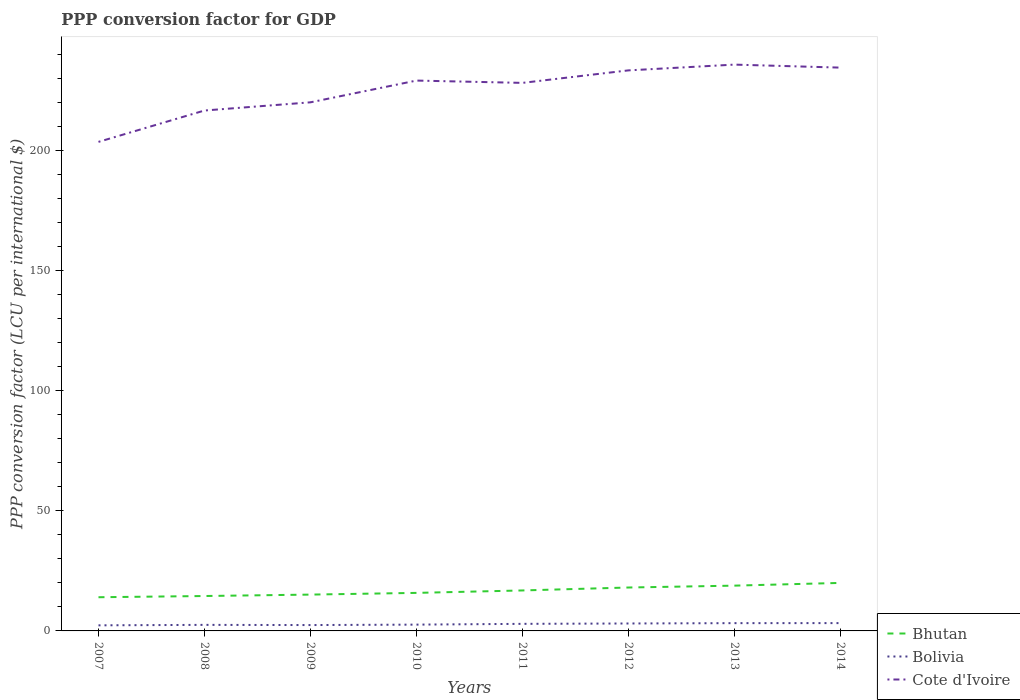Does the line corresponding to Bhutan intersect with the line corresponding to Bolivia?
Keep it short and to the point. No. Is the number of lines equal to the number of legend labels?
Make the answer very short. Yes. Across all years, what is the maximum PPP conversion factor for GDP in Bolivia?
Your answer should be compact. 2.33. In which year was the PPP conversion factor for GDP in Bolivia maximum?
Offer a terse response. 2007. What is the total PPP conversion factor for GDP in Cote d'Ivoire in the graph?
Ensure brevity in your answer.  -6.65. What is the difference between the highest and the second highest PPP conversion factor for GDP in Bolivia?
Ensure brevity in your answer.  0.93. Is the PPP conversion factor for GDP in Bolivia strictly greater than the PPP conversion factor for GDP in Cote d'Ivoire over the years?
Keep it short and to the point. Yes. How many lines are there?
Keep it short and to the point. 3. How many years are there in the graph?
Ensure brevity in your answer.  8. What is the difference between two consecutive major ticks on the Y-axis?
Make the answer very short. 50. Does the graph contain any zero values?
Offer a terse response. No. How many legend labels are there?
Provide a succinct answer. 3. How are the legend labels stacked?
Make the answer very short. Vertical. What is the title of the graph?
Ensure brevity in your answer.  PPP conversion factor for GDP. What is the label or title of the X-axis?
Provide a succinct answer. Years. What is the label or title of the Y-axis?
Offer a very short reply. PPP conversion factor (LCU per international $). What is the PPP conversion factor (LCU per international $) of Bhutan in 2007?
Provide a short and direct response. 14.03. What is the PPP conversion factor (LCU per international $) of Bolivia in 2007?
Your answer should be compact. 2.33. What is the PPP conversion factor (LCU per international $) in Cote d'Ivoire in 2007?
Ensure brevity in your answer.  203.66. What is the PPP conversion factor (LCU per international $) of Bhutan in 2008?
Your answer should be very brief. 14.54. What is the PPP conversion factor (LCU per international $) of Bolivia in 2008?
Ensure brevity in your answer.  2.52. What is the PPP conversion factor (LCU per international $) in Cote d'Ivoire in 2008?
Keep it short and to the point. 216.72. What is the PPP conversion factor (LCU per international $) of Bhutan in 2009?
Your answer should be very brief. 15.13. What is the PPP conversion factor (LCU per international $) of Bolivia in 2009?
Ensure brevity in your answer.  2.44. What is the PPP conversion factor (LCU per international $) of Cote d'Ivoire in 2009?
Your response must be concise. 220.13. What is the PPP conversion factor (LCU per international $) in Bhutan in 2010?
Give a very brief answer. 15.84. What is the PPP conversion factor (LCU per international $) in Bolivia in 2010?
Offer a terse response. 2.62. What is the PPP conversion factor (LCU per international $) in Cote d'Ivoire in 2010?
Keep it short and to the point. 229.19. What is the PPP conversion factor (LCU per international $) in Bhutan in 2011?
Your response must be concise. 16.86. What is the PPP conversion factor (LCU per international $) of Bolivia in 2011?
Your answer should be very brief. 2.95. What is the PPP conversion factor (LCU per international $) of Cote d'Ivoire in 2011?
Make the answer very short. 228.23. What is the PPP conversion factor (LCU per international $) of Bhutan in 2012?
Make the answer very short. 18.08. What is the PPP conversion factor (LCU per international $) of Bolivia in 2012?
Offer a terse response. 3.1. What is the PPP conversion factor (LCU per international $) in Cote d'Ivoire in 2012?
Your answer should be very brief. 233.43. What is the PPP conversion factor (LCU per international $) of Bhutan in 2013?
Provide a succinct answer. 18.86. What is the PPP conversion factor (LCU per international $) in Bolivia in 2013?
Offer a terse response. 3.24. What is the PPP conversion factor (LCU per international $) in Cote d'Ivoire in 2013?
Keep it short and to the point. 235.84. What is the PPP conversion factor (LCU per international $) of Bhutan in 2014?
Keep it short and to the point. 19.99. What is the PPP conversion factor (LCU per international $) in Bolivia in 2014?
Offer a very short reply. 3.26. What is the PPP conversion factor (LCU per international $) in Cote d'Ivoire in 2014?
Give a very brief answer. 234.59. Across all years, what is the maximum PPP conversion factor (LCU per international $) of Bhutan?
Keep it short and to the point. 19.99. Across all years, what is the maximum PPP conversion factor (LCU per international $) in Bolivia?
Your answer should be compact. 3.26. Across all years, what is the maximum PPP conversion factor (LCU per international $) of Cote d'Ivoire?
Your response must be concise. 235.84. Across all years, what is the minimum PPP conversion factor (LCU per international $) in Bhutan?
Offer a terse response. 14.03. Across all years, what is the minimum PPP conversion factor (LCU per international $) of Bolivia?
Provide a succinct answer. 2.33. Across all years, what is the minimum PPP conversion factor (LCU per international $) in Cote d'Ivoire?
Keep it short and to the point. 203.66. What is the total PPP conversion factor (LCU per international $) in Bhutan in the graph?
Keep it short and to the point. 133.32. What is the total PPP conversion factor (LCU per international $) in Bolivia in the graph?
Your response must be concise. 22.45. What is the total PPP conversion factor (LCU per international $) in Cote d'Ivoire in the graph?
Provide a short and direct response. 1801.79. What is the difference between the PPP conversion factor (LCU per international $) of Bhutan in 2007 and that in 2008?
Keep it short and to the point. -0.51. What is the difference between the PPP conversion factor (LCU per international $) of Bolivia in 2007 and that in 2008?
Your answer should be very brief. -0.19. What is the difference between the PPP conversion factor (LCU per international $) of Cote d'Ivoire in 2007 and that in 2008?
Keep it short and to the point. -13.06. What is the difference between the PPP conversion factor (LCU per international $) of Bhutan in 2007 and that in 2009?
Your response must be concise. -1.1. What is the difference between the PPP conversion factor (LCU per international $) in Bolivia in 2007 and that in 2009?
Ensure brevity in your answer.  -0.11. What is the difference between the PPP conversion factor (LCU per international $) in Cote d'Ivoire in 2007 and that in 2009?
Give a very brief answer. -16.48. What is the difference between the PPP conversion factor (LCU per international $) in Bhutan in 2007 and that in 2010?
Your answer should be very brief. -1.81. What is the difference between the PPP conversion factor (LCU per international $) of Bolivia in 2007 and that in 2010?
Provide a succinct answer. -0.29. What is the difference between the PPP conversion factor (LCU per international $) of Cote d'Ivoire in 2007 and that in 2010?
Your answer should be compact. -25.53. What is the difference between the PPP conversion factor (LCU per international $) of Bhutan in 2007 and that in 2011?
Give a very brief answer. -2.83. What is the difference between the PPP conversion factor (LCU per international $) in Bolivia in 2007 and that in 2011?
Keep it short and to the point. -0.62. What is the difference between the PPP conversion factor (LCU per international $) in Cote d'Ivoire in 2007 and that in 2011?
Provide a short and direct response. -24.57. What is the difference between the PPP conversion factor (LCU per international $) of Bhutan in 2007 and that in 2012?
Ensure brevity in your answer.  -4.05. What is the difference between the PPP conversion factor (LCU per international $) of Bolivia in 2007 and that in 2012?
Provide a short and direct response. -0.77. What is the difference between the PPP conversion factor (LCU per international $) of Cote d'Ivoire in 2007 and that in 2012?
Provide a short and direct response. -29.78. What is the difference between the PPP conversion factor (LCU per international $) in Bhutan in 2007 and that in 2013?
Offer a very short reply. -4.83. What is the difference between the PPP conversion factor (LCU per international $) in Bolivia in 2007 and that in 2013?
Keep it short and to the point. -0.91. What is the difference between the PPP conversion factor (LCU per international $) of Cote d'Ivoire in 2007 and that in 2013?
Your response must be concise. -32.18. What is the difference between the PPP conversion factor (LCU per international $) in Bhutan in 2007 and that in 2014?
Keep it short and to the point. -5.96. What is the difference between the PPP conversion factor (LCU per international $) in Bolivia in 2007 and that in 2014?
Make the answer very short. -0.93. What is the difference between the PPP conversion factor (LCU per international $) of Cote d'Ivoire in 2007 and that in 2014?
Your answer should be compact. -30.93. What is the difference between the PPP conversion factor (LCU per international $) of Bhutan in 2008 and that in 2009?
Make the answer very short. -0.59. What is the difference between the PPP conversion factor (LCU per international $) in Bolivia in 2008 and that in 2009?
Your answer should be very brief. 0.08. What is the difference between the PPP conversion factor (LCU per international $) in Cote d'Ivoire in 2008 and that in 2009?
Offer a very short reply. -3.41. What is the difference between the PPP conversion factor (LCU per international $) in Bhutan in 2008 and that in 2010?
Your answer should be compact. -1.3. What is the difference between the PPP conversion factor (LCU per international $) in Bolivia in 2008 and that in 2010?
Keep it short and to the point. -0.1. What is the difference between the PPP conversion factor (LCU per international $) of Cote d'Ivoire in 2008 and that in 2010?
Your answer should be compact. -12.47. What is the difference between the PPP conversion factor (LCU per international $) in Bhutan in 2008 and that in 2011?
Give a very brief answer. -2.32. What is the difference between the PPP conversion factor (LCU per international $) in Bolivia in 2008 and that in 2011?
Provide a short and direct response. -0.42. What is the difference between the PPP conversion factor (LCU per international $) of Cote d'Ivoire in 2008 and that in 2011?
Make the answer very short. -11.51. What is the difference between the PPP conversion factor (LCU per international $) of Bhutan in 2008 and that in 2012?
Provide a short and direct response. -3.54. What is the difference between the PPP conversion factor (LCU per international $) in Bolivia in 2008 and that in 2012?
Give a very brief answer. -0.58. What is the difference between the PPP conversion factor (LCU per international $) of Cote d'Ivoire in 2008 and that in 2012?
Ensure brevity in your answer.  -16.71. What is the difference between the PPP conversion factor (LCU per international $) of Bhutan in 2008 and that in 2013?
Keep it short and to the point. -4.32. What is the difference between the PPP conversion factor (LCU per international $) of Bolivia in 2008 and that in 2013?
Provide a succinct answer. -0.72. What is the difference between the PPP conversion factor (LCU per international $) of Cote d'Ivoire in 2008 and that in 2013?
Keep it short and to the point. -19.12. What is the difference between the PPP conversion factor (LCU per international $) of Bhutan in 2008 and that in 2014?
Ensure brevity in your answer.  -5.46. What is the difference between the PPP conversion factor (LCU per international $) of Bolivia in 2008 and that in 2014?
Offer a very short reply. -0.73. What is the difference between the PPP conversion factor (LCU per international $) of Cote d'Ivoire in 2008 and that in 2014?
Make the answer very short. -17.86. What is the difference between the PPP conversion factor (LCU per international $) of Bhutan in 2009 and that in 2010?
Give a very brief answer. -0.71. What is the difference between the PPP conversion factor (LCU per international $) of Bolivia in 2009 and that in 2010?
Your answer should be very brief. -0.18. What is the difference between the PPP conversion factor (LCU per international $) of Cote d'Ivoire in 2009 and that in 2010?
Your response must be concise. -9.06. What is the difference between the PPP conversion factor (LCU per international $) of Bhutan in 2009 and that in 2011?
Offer a very short reply. -1.73. What is the difference between the PPP conversion factor (LCU per international $) of Bolivia in 2009 and that in 2011?
Your answer should be compact. -0.5. What is the difference between the PPP conversion factor (LCU per international $) in Cote d'Ivoire in 2009 and that in 2011?
Offer a terse response. -8.09. What is the difference between the PPP conversion factor (LCU per international $) in Bhutan in 2009 and that in 2012?
Your answer should be very brief. -2.95. What is the difference between the PPP conversion factor (LCU per international $) in Bolivia in 2009 and that in 2012?
Ensure brevity in your answer.  -0.66. What is the difference between the PPP conversion factor (LCU per international $) in Cote d'Ivoire in 2009 and that in 2012?
Give a very brief answer. -13.3. What is the difference between the PPP conversion factor (LCU per international $) of Bhutan in 2009 and that in 2013?
Give a very brief answer. -3.73. What is the difference between the PPP conversion factor (LCU per international $) of Bolivia in 2009 and that in 2013?
Your answer should be compact. -0.8. What is the difference between the PPP conversion factor (LCU per international $) in Cote d'Ivoire in 2009 and that in 2013?
Make the answer very short. -15.7. What is the difference between the PPP conversion factor (LCU per international $) in Bhutan in 2009 and that in 2014?
Provide a short and direct response. -4.87. What is the difference between the PPP conversion factor (LCU per international $) of Bolivia in 2009 and that in 2014?
Your answer should be very brief. -0.81. What is the difference between the PPP conversion factor (LCU per international $) in Cote d'Ivoire in 2009 and that in 2014?
Offer a terse response. -14.45. What is the difference between the PPP conversion factor (LCU per international $) in Bhutan in 2010 and that in 2011?
Ensure brevity in your answer.  -1.02. What is the difference between the PPP conversion factor (LCU per international $) in Bolivia in 2010 and that in 2011?
Your answer should be compact. -0.32. What is the difference between the PPP conversion factor (LCU per international $) of Cote d'Ivoire in 2010 and that in 2011?
Your answer should be compact. 0.96. What is the difference between the PPP conversion factor (LCU per international $) in Bhutan in 2010 and that in 2012?
Give a very brief answer. -2.24. What is the difference between the PPP conversion factor (LCU per international $) of Bolivia in 2010 and that in 2012?
Provide a short and direct response. -0.48. What is the difference between the PPP conversion factor (LCU per international $) of Cote d'Ivoire in 2010 and that in 2012?
Your answer should be very brief. -4.24. What is the difference between the PPP conversion factor (LCU per international $) in Bhutan in 2010 and that in 2013?
Provide a succinct answer. -3.02. What is the difference between the PPP conversion factor (LCU per international $) in Bolivia in 2010 and that in 2013?
Provide a succinct answer. -0.61. What is the difference between the PPP conversion factor (LCU per international $) in Cote d'Ivoire in 2010 and that in 2013?
Make the answer very short. -6.65. What is the difference between the PPP conversion factor (LCU per international $) of Bhutan in 2010 and that in 2014?
Provide a short and direct response. -4.15. What is the difference between the PPP conversion factor (LCU per international $) of Bolivia in 2010 and that in 2014?
Your response must be concise. -0.63. What is the difference between the PPP conversion factor (LCU per international $) in Cote d'Ivoire in 2010 and that in 2014?
Your response must be concise. -5.39. What is the difference between the PPP conversion factor (LCU per international $) in Bhutan in 2011 and that in 2012?
Make the answer very short. -1.22. What is the difference between the PPP conversion factor (LCU per international $) of Bolivia in 2011 and that in 2012?
Your answer should be very brief. -0.15. What is the difference between the PPP conversion factor (LCU per international $) in Cote d'Ivoire in 2011 and that in 2012?
Make the answer very short. -5.21. What is the difference between the PPP conversion factor (LCU per international $) in Bhutan in 2011 and that in 2013?
Ensure brevity in your answer.  -2. What is the difference between the PPP conversion factor (LCU per international $) of Bolivia in 2011 and that in 2013?
Provide a short and direct response. -0.29. What is the difference between the PPP conversion factor (LCU per international $) of Cote d'Ivoire in 2011 and that in 2013?
Ensure brevity in your answer.  -7.61. What is the difference between the PPP conversion factor (LCU per international $) of Bhutan in 2011 and that in 2014?
Provide a short and direct response. -3.14. What is the difference between the PPP conversion factor (LCU per international $) in Bolivia in 2011 and that in 2014?
Your answer should be compact. -0.31. What is the difference between the PPP conversion factor (LCU per international $) of Cote d'Ivoire in 2011 and that in 2014?
Offer a very short reply. -6.36. What is the difference between the PPP conversion factor (LCU per international $) of Bhutan in 2012 and that in 2013?
Make the answer very short. -0.78. What is the difference between the PPP conversion factor (LCU per international $) in Bolivia in 2012 and that in 2013?
Your response must be concise. -0.14. What is the difference between the PPP conversion factor (LCU per international $) of Cote d'Ivoire in 2012 and that in 2013?
Provide a succinct answer. -2.4. What is the difference between the PPP conversion factor (LCU per international $) of Bhutan in 2012 and that in 2014?
Give a very brief answer. -1.92. What is the difference between the PPP conversion factor (LCU per international $) of Bolivia in 2012 and that in 2014?
Offer a terse response. -0.16. What is the difference between the PPP conversion factor (LCU per international $) in Cote d'Ivoire in 2012 and that in 2014?
Provide a short and direct response. -1.15. What is the difference between the PPP conversion factor (LCU per international $) in Bhutan in 2013 and that in 2014?
Provide a short and direct response. -1.14. What is the difference between the PPP conversion factor (LCU per international $) in Bolivia in 2013 and that in 2014?
Keep it short and to the point. -0.02. What is the difference between the PPP conversion factor (LCU per international $) of Cote d'Ivoire in 2013 and that in 2014?
Ensure brevity in your answer.  1.25. What is the difference between the PPP conversion factor (LCU per international $) of Bhutan in 2007 and the PPP conversion factor (LCU per international $) of Bolivia in 2008?
Make the answer very short. 11.51. What is the difference between the PPP conversion factor (LCU per international $) in Bhutan in 2007 and the PPP conversion factor (LCU per international $) in Cote d'Ivoire in 2008?
Offer a terse response. -202.69. What is the difference between the PPP conversion factor (LCU per international $) in Bolivia in 2007 and the PPP conversion factor (LCU per international $) in Cote d'Ivoire in 2008?
Your response must be concise. -214.39. What is the difference between the PPP conversion factor (LCU per international $) in Bhutan in 2007 and the PPP conversion factor (LCU per international $) in Bolivia in 2009?
Provide a succinct answer. 11.59. What is the difference between the PPP conversion factor (LCU per international $) in Bhutan in 2007 and the PPP conversion factor (LCU per international $) in Cote d'Ivoire in 2009?
Give a very brief answer. -206.1. What is the difference between the PPP conversion factor (LCU per international $) in Bolivia in 2007 and the PPP conversion factor (LCU per international $) in Cote d'Ivoire in 2009?
Make the answer very short. -217.81. What is the difference between the PPP conversion factor (LCU per international $) of Bhutan in 2007 and the PPP conversion factor (LCU per international $) of Bolivia in 2010?
Your response must be concise. 11.41. What is the difference between the PPP conversion factor (LCU per international $) of Bhutan in 2007 and the PPP conversion factor (LCU per international $) of Cote d'Ivoire in 2010?
Offer a terse response. -215.16. What is the difference between the PPP conversion factor (LCU per international $) of Bolivia in 2007 and the PPP conversion factor (LCU per international $) of Cote d'Ivoire in 2010?
Ensure brevity in your answer.  -226.86. What is the difference between the PPP conversion factor (LCU per international $) in Bhutan in 2007 and the PPP conversion factor (LCU per international $) in Bolivia in 2011?
Your answer should be compact. 11.08. What is the difference between the PPP conversion factor (LCU per international $) in Bhutan in 2007 and the PPP conversion factor (LCU per international $) in Cote d'Ivoire in 2011?
Provide a short and direct response. -214.2. What is the difference between the PPP conversion factor (LCU per international $) in Bolivia in 2007 and the PPP conversion factor (LCU per international $) in Cote d'Ivoire in 2011?
Your answer should be compact. -225.9. What is the difference between the PPP conversion factor (LCU per international $) of Bhutan in 2007 and the PPP conversion factor (LCU per international $) of Bolivia in 2012?
Ensure brevity in your answer.  10.93. What is the difference between the PPP conversion factor (LCU per international $) in Bhutan in 2007 and the PPP conversion factor (LCU per international $) in Cote d'Ivoire in 2012?
Offer a very short reply. -219.4. What is the difference between the PPP conversion factor (LCU per international $) in Bolivia in 2007 and the PPP conversion factor (LCU per international $) in Cote d'Ivoire in 2012?
Ensure brevity in your answer.  -231.11. What is the difference between the PPP conversion factor (LCU per international $) of Bhutan in 2007 and the PPP conversion factor (LCU per international $) of Bolivia in 2013?
Give a very brief answer. 10.79. What is the difference between the PPP conversion factor (LCU per international $) in Bhutan in 2007 and the PPP conversion factor (LCU per international $) in Cote d'Ivoire in 2013?
Keep it short and to the point. -221.81. What is the difference between the PPP conversion factor (LCU per international $) of Bolivia in 2007 and the PPP conversion factor (LCU per international $) of Cote d'Ivoire in 2013?
Offer a terse response. -233.51. What is the difference between the PPP conversion factor (LCU per international $) in Bhutan in 2007 and the PPP conversion factor (LCU per international $) in Bolivia in 2014?
Keep it short and to the point. 10.77. What is the difference between the PPP conversion factor (LCU per international $) in Bhutan in 2007 and the PPP conversion factor (LCU per international $) in Cote d'Ivoire in 2014?
Your answer should be compact. -220.56. What is the difference between the PPP conversion factor (LCU per international $) in Bolivia in 2007 and the PPP conversion factor (LCU per international $) in Cote d'Ivoire in 2014?
Provide a succinct answer. -232.26. What is the difference between the PPP conversion factor (LCU per international $) of Bhutan in 2008 and the PPP conversion factor (LCU per international $) of Bolivia in 2009?
Provide a succinct answer. 12.1. What is the difference between the PPP conversion factor (LCU per international $) of Bhutan in 2008 and the PPP conversion factor (LCU per international $) of Cote d'Ivoire in 2009?
Keep it short and to the point. -205.6. What is the difference between the PPP conversion factor (LCU per international $) of Bolivia in 2008 and the PPP conversion factor (LCU per international $) of Cote d'Ivoire in 2009?
Offer a terse response. -217.61. What is the difference between the PPP conversion factor (LCU per international $) in Bhutan in 2008 and the PPP conversion factor (LCU per international $) in Bolivia in 2010?
Your response must be concise. 11.91. What is the difference between the PPP conversion factor (LCU per international $) of Bhutan in 2008 and the PPP conversion factor (LCU per international $) of Cote d'Ivoire in 2010?
Ensure brevity in your answer.  -214.65. What is the difference between the PPP conversion factor (LCU per international $) in Bolivia in 2008 and the PPP conversion factor (LCU per international $) in Cote d'Ivoire in 2010?
Keep it short and to the point. -226.67. What is the difference between the PPP conversion factor (LCU per international $) of Bhutan in 2008 and the PPP conversion factor (LCU per international $) of Bolivia in 2011?
Your answer should be very brief. 11.59. What is the difference between the PPP conversion factor (LCU per international $) in Bhutan in 2008 and the PPP conversion factor (LCU per international $) in Cote d'Ivoire in 2011?
Give a very brief answer. -213.69. What is the difference between the PPP conversion factor (LCU per international $) of Bolivia in 2008 and the PPP conversion factor (LCU per international $) of Cote d'Ivoire in 2011?
Keep it short and to the point. -225.71. What is the difference between the PPP conversion factor (LCU per international $) in Bhutan in 2008 and the PPP conversion factor (LCU per international $) in Bolivia in 2012?
Keep it short and to the point. 11.44. What is the difference between the PPP conversion factor (LCU per international $) of Bhutan in 2008 and the PPP conversion factor (LCU per international $) of Cote d'Ivoire in 2012?
Your response must be concise. -218.9. What is the difference between the PPP conversion factor (LCU per international $) of Bolivia in 2008 and the PPP conversion factor (LCU per international $) of Cote d'Ivoire in 2012?
Keep it short and to the point. -230.91. What is the difference between the PPP conversion factor (LCU per international $) of Bhutan in 2008 and the PPP conversion factor (LCU per international $) of Bolivia in 2013?
Provide a short and direct response. 11.3. What is the difference between the PPP conversion factor (LCU per international $) of Bhutan in 2008 and the PPP conversion factor (LCU per international $) of Cote d'Ivoire in 2013?
Offer a very short reply. -221.3. What is the difference between the PPP conversion factor (LCU per international $) in Bolivia in 2008 and the PPP conversion factor (LCU per international $) in Cote d'Ivoire in 2013?
Make the answer very short. -233.32. What is the difference between the PPP conversion factor (LCU per international $) in Bhutan in 2008 and the PPP conversion factor (LCU per international $) in Bolivia in 2014?
Your response must be concise. 11.28. What is the difference between the PPP conversion factor (LCU per international $) in Bhutan in 2008 and the PPP conversion factor (LCU per international $) in Cote d'Ivoire in 2014?
Your answer should be compact. -220.05. What is the difference between the PPP conversion factor (LCU per international $) of Bolivia in 2008 and the PPP conversion factor (LCU per international $) of Cote d'Ivoire in 2014?
Ensure brevity in your answer.  -232.07. What is the difference between the PPP conversion factor (LCU per international $) of Bhutan in 2009 and the PPP conversion factor (LCU per international $) of Bolivia in 2010?
Offer a terse response. 12.5. What is the difference between the PPP conversion factor (LCU per international $) of Bhutan in 2009 and the PPP conversion factor (LCU per international $) of Cote d'Ivoire in 2010?
Provide a short and direct response. -214.06. What is the difference between the PPP conversion factor (LCU per international $) in Bolivia in 2009 and the PPP conversion factor (LCU per international $) in Cote d'Ivoire in 2010?
Your response must be concise. -226.75. What is the difference between the PPP conversion factor (LCU per international $) of Bhutan in 2009 and the PPP conversion factor (LCU per international $) of Bolivia in 2011?
Your answer should be compact. 12.18. What is the difference between the PPP conversion factor (LCU per international $) in Bhutan in 2009 and the PPP conversion factor (LCU per international $) in Cote d'Ivoire in 2011?
Offer a terse response. -213.1. What is the difference between the PPP conversion factor (LCU per international $) in Bolivia in 2009 and the PPP conversion factor (LCU per international $) in Cote d'Ivoire in 2011?
Your answer should be very brief. -225.79. What is the difference between the PPP conversion factor (LCU per international $) in Bhutan in 2009 and the PPP conversion factor (LCU per international $) in Bolivia in 2012?
Provide a short and direct response. 12.03. What is the difference between the PPP conversion factor (LCU per international $) of Bhutan in 2009 and the PPP conversion factor (LCU per international $) of Cote d'Ivoire in 2012?
Provide a succinct answer. -218.31. What is the difference between the PPP conversion factor (LCU per international $) in Bolivia in 2009 and the PPP conversion factor (LCU per international $) in Cote d'Ivoire in 2012?
Ensure brevity in your answer.  -230.99. What is the difference between the PPP conversion factor (LCU per international $) in Bhutan in 2009 and the PPP conversion factor (LCU per international $) in Bolivia in 2013?
Provide a succinct answer. 11.89. What is the difference between the PPP conversion factor (LCU per international $) of Bhutan in 2009 and the PPP conversion factor (LCU per international $) of Cote d'Ivoire in 2013?
Your answer should be compact. -220.71. What is the difference between the PPP conversion factor (LCU per international $) in Bolivia in 2009 and the PPP conversion factor (LCU per international $) in Cote d'Ivoire in 2013?
Provide a short and direct response. -233.4. What is the difference between the PPP conversion factor (LCU per international $) in Bhutan in 2009 and the PPP conversion factor (LCU per international $) in Bolivia in 2014?
Offer a terse response. 11.87. What is the difference between the PPP conversion factor (LCU per international $) in Bhutan in 2009 and the PPP conversion factor (LCU per international $) in Cote d'Ivoire in 2014?
Provide a short and direct response. -219.46. What is the difference between the PPP conversion factor (LCU per international $) of Bolivia in 2009 and the PPP conversion factor (LCU per international $) of Cote d'Ivoire in 2014?
Provide a short and direct response. -232.14. What is the difference between the PPP conversion factor (LCU per international $) in Bhutan in 2010 and the PPP conversion factor (LCU per international $) in Bolivia in 2011?
Your answer should be very brief. 12.89. What is the difference between the PPP conversion factor (LCU per international $) in Bhutan in 2010 and the PPP conversion factor (LCU per international $) in Cote d'Ivoire in 2011?
Give a very brief answer. -212.39. What is the difference between the PPP conversion factor (LCU per international $) of Bolivia in 2010 and the PPP conversion factor (LCU per international $) of Cote d'Ivoire in 2011?
Your response must be concise. -225.6. What is the difference between the PPP conversion factor (LCU per international $) in Bhutan in 2010 and the PPP conversion factor (LCU per international $) in Bolivia in 2012?
Provide a succinct answer. 12.74. What is the difference between the PPP conversion factor (LCU per international $) in Bhutan in 2010 and the PPP conversion factor (LCU per international $) in Cote d'Ivoire in 2012?
Offer a very short reply. -217.59. What is the difference between the PPP conversion factor (LCU per international $) in Bolivia in 2010 and the PPP conversion factor (LCU per international $) in Cote d'Ivoire in 2012?
Your answer should be very brief. -230.81. What is the difference between the PPP conversion factor (LCU per international $) of Bhutan in 2010 and the PPP conversion factor (LCU per international $) of Bolivia in 2013?
Your answer should be compact. 12.6. What is the difference between the PPP conversion factor (LCU per international $) of Bhutan in 2010 and the PPP conversion factor (LCU per international $) of Cote d'Ivoire in 2013?
Your response must be concise. -220. What is the difference between the PPP conversion factor (LCU per international $) in Bolivia in 2010 and the PPP conversion factor (LCU per international $) in Cote d'Ivoire in 2013?
Keep it short and to the point. -233.21. What is the difference between the PPP conversion factor (LCU per international $) of Bhutan in 2010 and the PPP conversion factor (LCU per international $) of Bolivia in 2014?
Give a very brief answer. 12.58. What is the difference between the PPP conversion factor (LCU per international $) in Bhutan in 2010 and the PPP conversion factor (LCU per international $) in Cote d'Ivoire in 2014?
Provide a short and direct response. -218.75. What is the difference between the PPP conversion factor (LCU per international $) of Bolivia in 2010 and the PPP conversion factor (LCU per international $) of Cote d'Ivoire in 2014?
Provide a succinct answer. -231.96. What is the difference between the PPP conversion factor (LCU per international $) of Bhutan in 2011 and the PPP conversion factor (LCU per international $) of Bolivia in 2012?
Offer a terse response. 13.76. What is the difference between the PPP conversion factor (LCU per international $) of Bhutan in 2011 and the PPP conversion factor (LCU per international $) of Cote d'Ivoire in 2012?
Your answer should be very brief. -216.58. What is the difference between the PPP conversion factor (LCU per international $) in Bolivia in 2011 and the PPP conversion factor (LCU per international $) in Cote d'Ivoire in 2012?
Provide a short and direct response. -230.49. What is the difference between the PPP conversion factor (LCU per international $) in Bhutan in 2011 and the PPP conversion factor (LCU per international $) in Bolivia in 2013?
Make the answer very short. 13.62. What is the difference between the PPP conversion factor (LCU per international $) of Bhutan in 2011 and the PPP conversion factor (LCU per international $) of Cote d'Ivoire in 2013?
Ensure brevity in your answer.  -218.98. What is the difference between the PPP conversion factor (LCU per international $) in Bolivia in 2011 and the PPP conversion factor (LCU per international $) in Cote d'Ivoire in 2013?
Your response must be concise. -232.89. What is the difference between the PPP conversion factor (LCU per international $) in Bhutan in 2011 and the PPP conversion factor (LCU per international $) in Bolivia in 2014?
Your answer should be compact. 13.6. What is the difference between the PPP conversion factor (LCU per international $) in Bhutan in 2011 and the PPP conversion factor (LCU per international $) in Cote d'Ivoire in 2014?
Your answer should be compact. -217.73. What is the difference between the PPP conversion factor (LCU per international $) of Bolivia in 2011 and the PPP conversion factor (LCU per international $) of Cote d'Ivoire in 2014?
Give a very brief answer. -231.64. What is the difference between the PPP conversion factor (LCU per international $) in Bhutan in 2012 and the PPP conversion factor (LCU per international $) in Bolivia in 2013?
Your answer should be compact. 14.84. What is the difference between the PPP conversion factor (LCU per international $) of Bhutan in 2012 and the PPP conversion factor (LCU per international $) of Cote d'Ivoire in 2013?
Your answer should be very brief. -217.76. What is the difference between the PPP conversion factor (LCU per international $) of Bolivia in 2012 and the PPP conversion factor (LCU per international $) of Cote d'Ivoire in 2013?
Your answer should be compact. -232.74. What is the difference between the PPP conversion factor (LCU per international $) of Bhutan in 2012 and the PPP conversion factor (LCU per international $) of Bolivia in 2014?
Your answer should be very brief. 14.82. What is the difference between the PPP conversion factor (LCU per international $) in Bhutan in 2012 and the PPP conversion factor (LCU per international $) in Cote d'Ivoire in 2014?
Offer a terse response. -216.51. What is the difference between the PPP conversion factor (LCU per international $) of Bolivia in 2012 and the PPP conversion factor (LCU per international $) of Cote d'Ivoire in 2014?
Offer a terse response. -231.49. What is the difference between the PPP conversion factor (LCU per international $) of Bhutan in 2013 and the PPP conversion factor (LCU per international $) of Bolivia in 2014?
Keep it short and to the point. 15.6. What is the difference between the PPP conversion factor (LCU per international $) of Bhutan in 2013 and the PPP conversion factor (LCU per international $) of Cote d'Ivoire in 2014?
Your answer should be compact. -215.73. What is the difference between the PPP conversion factor (LCU per international $) of Bolivia in 2013 and the PPP conversion factor (LCU per international $) of Cote d'Ivoire in 2014?
Provide a succinct answer. -231.35. What is the average PPP conversion factor (LCU per international $) of Bhutan per year?
Your answer should be very brief. 16.67. What is the average PPP conversion factor (LCU per international $) of Bolivia per year?
Ensure brevity in your answer.  2.81. What is the average PPP conversion factor (LCU per international $) of Cote d'Ivoire per year?
Your response must be concise. 225.22. In the year 2007, what is the difference between the PPP conversion factor (LCU per international $) of Bhutan and PPP conversion factor (LCU per international $) of Bolivia?
Make the answer very short. 11.7. In the year 2007, what is the difference between the PPP conversion factor (LCU per international $) of Bhutan and PPP conversion factor (LCU per international $) of Cote d'Ivoire?
Keep it short and to the point. -189.63. In the year 2007, what is the difference between the PPP conversion factor (LCU per international $) of Bolivia and PPP conversion factor (LCU per international $) of Cote d'Ivoire?
Your answer should be very brief. -201.33. In the year 2008, what is the difference between the PPP conversion factor (LCU per international $) of Bhutan and PPP conversion factor (LCU per international $) of Bolivia?
Offer a terse response. 12.02. In the year 2008, what is the difference between the PPP conversion factor (LCU per international $) of Bhutan and PPP conversion factor (LCU per international $) of Cote d'Ivoire?
Your answer should be very brief. -202.18. In the year 2008, what is the difference between the PPP conversion factor (LCU per international $) in Bolivia and PPP conversion factor (LCU per international $) in Cote d'Ivoire?
Offer a very short reply. -214.2. In the year 2009, what is the difference between the PPP conversion factor (LCU per international $) of Bhutan and PPP conversion factor (LCU per international $) of Bolivia?
Offer a very short reply. 12.69. In the year 2009, what is the difference between the PPP conversion factor (LCU per international $) of Bhutan and PPP conversion factor (LCU per international $) of Cote d'Ivoire?
Your answer should be very brief. -205.01. In the year 2009, what is the difference between the PPP conversion factor (LCU per international $) in Bolivia and PPP conversion factor (LCU per international $) in Cote d'Ivoire?
Offer a terse response. -217.69. In the year 2010, what is the difference between the PPP conversion factor (LCU per international $) of Bhutan and PPP conversion factor (LCU per international $) of Bolivia?
Your response must be concise. 13.22. In the year 2010, what is the difference between the PPP conversion factor (LCU per international $) of Bhutan and PPP conversion factor (LCU per international $) of Cote d'Ivoire?
Provide a succinct answer. -213.35. In the year 2010, what is the difference between the PPP conversion factor (LCU per international $) of Bolivia and PPP conversion factor (LCU per international $) of Cote d'Ivoire?
Offer a terse response. -226.57. In the year 2011, what is the difference between the PPP conversion factor (LCU per international $) in Bhutan and PPP conversion factor (LCU per international $) in Bolivia?
Your answer should be compact. 13.91. In the year 2011, what is the difference between the PPP conversion factor (LCU per international $) of Bhutan and PPP conversion factor (LCU per international $) of Cote d'Ivoire?
Give a very brief answer. -211.37. In the year 2011, what is the difference between the PPP conversion factor (LCU per international $) in Bolivia and PPP conversion factor (LCU per international $) in Cote d'Ivoire?
Provide a succinct answer. -225.28. In the year 2012, what is the difference between the PPP conversion factor (LCU per international $) in Bhutan and PPP conversion factor (LCU per international $) in Bolivia?
Make the answer very short. 14.98. In the year 2012, what is the difference between the PPP conversion factor (LCU per international $) in Bhutan and PPP conversion factor (LCU per international $) in Cote d'Ivoire?
Keep it short and to the point. -215.36. In the year 2012, what is the difference between the PPP conversion factor (LCU per international $) in Bolivia and PPP conversion factor (LCU per international $) in Cote d'Ivoire?
Give a very brief answer. -230.34. In the year 2013, what is the difference between the PPP conversion factor (LCU per international $) in Bhutan and PPP conversion factor (LCU per international $) in Bolivia?
Offer a very short reply. 15.62. In the year 2013, what is the difference between the PPP conversion factor (LCU per international $) in Bhutan and PPP conversion factor (LCU per international $) in Cote d'Ivoire?
Offer a terse response. -216.98. In the year 2013, what is the difference between the PPP conversion factor (LCU per international $) in Bolivia and PPP conversion factor (LCU per international $) in Cote d'Ivoire?
Provide a succinct answer. -232.6. In the year 2014, what is the difference between the PPP conversion factor (LCU per international $) of Bhutan and PPP conversion factor (LCU per international $) of Bolivia?
Make the answer very short. 16.74. In the year 2014, what is the difference between the PPP conversion factor (LCU per international $) of Bhutan and PPP conversion factor (LCU per international $) of Cote d'Ivoire?
Keep it short and to the point. -214.59. In the year 2014, what is the difference between the PPP conversion factor (LCU per international $) in Bolivia and PPP conversion factor (LCU per international $) in Cote d'Ivoire?
Your answer should be compact. -231.33. What is the ratio of the PPP conversion factor (LCU per international $) of Bhutan in 2007 to that in 2008?
Ensure brevity in your answer.  0.97. What is the ratio of the PPP conversion factor (LCU per international $) in Bolivia in 2007 to that in 2008?
Your answer should be very brief. 0.92. What is the ratio of the PPP conversion factor (LCU per international $) in Cote d'Ivoire in 2007 to that in 2008?
Your response must be concise. 0.94. What is the ratio of the PPP conversion factor (LCU per international $) in Bhutan in 2007 to that in 2009?
Give a very brief answer. 0.93. What is the ratio of the PPP conversion factor (LCU per international $) of Bolivia in 2007 to that in 2009?
Offer a very short reply. 0.95. What is the ratio of the PPP conversion factor (LCU per international $) in Cote d'Ivoire in 2007 to that in 2009?
Ensure brevity in your answer.  0.93. What is the ratio of the PPP conversion factor (LCU per international $) of Bhutan in 2007 to that in 2010?
Offer a terse response. 0.89. What is the ratio of the PPP conversion factor (LCU per international $) in Bolivia in 2007 to that in 2010?
Give a very brief answer. 0.89. What is the ratio of the PPP conversion factor (LCU per international $) in Cote d'Ivoire in 2007 to that in 2010?
Keep it short and to the point. 0.89. What is the ratio of the PPP conversion factor (LCU per international $) of Bhutan in 2007 to that in 2011?
Provide a short and direct response. 0.83. What is the ratio of the PPP conversion factor (LCU per international $) of Bolivia in 2007 to that in 2011?
Offer a very short reply. 0.79. What is the ratio of the PPP conversion factor (LCU per international $) in Cote d'Ivoire in 2007 to that in 2011?
Offer a terse response. 0.89. What is the ratio of the PPP conversion factor (LCU per international $) of Bhutan in 2007 to that in 2012?
Your answer should be very brief. 0.78. What is the ratio of the PPP conversion factor (LCU per international $) in Bolivia in 2007 to that in 2012?
Your response must be concise. 0.75. What is the ratio of the PPP conversion factor (LCU per international $) of Cote d'Ivoire in 2007 to that in 2012?
Keep it short and to the point. 0.87. What is the ratio of the PPP conversion factor (LCU per international $) in Bhutan in 2007 to that in 2013?
Your answer should be compact. 0.74. What is the ratio of the PPP conversion factor (LCU per international $) of Bolivia in 2007 to that in 2013?
Offer a terse response. 0.72. What is the ratio of the PPP conversion factor (LCU per international $) of Cote d'Ivoire in 2007 to that in 2013?
Provide a short and direct response. 0.86. What is the ratio of the PPP conversion factor (LCU per international $) of Bhutan in 2007 to that in 2014?
Keep it short and to the point. 0.7. What is the ratio of the PPP conversion factor (LCU per international $) in Bolivia in 2007 to that in 2014?
Offer a very short reply. 0.72. What is the ratio of the PPP conversion factor (LCU per international $) of Cote d'Ivoire in 2007 to that in 2014?
Give a very brief answer. 0.87. What is the ratio of the PPP conversion factor (LCU per international $) in Bolivia in 2008 to that in 2009?
Provide a succinct answer. 1.03. What is the ratio of the PPP conversion factor (LCU per international $) in Cote d'Ivoire in 2008 to that in 2009?
Offer a very short reply. 0.98. What is the ratio of the PPP conversion factor (LCU per international $) of Bhutan in 2008 to that in 2010?
Your answer should be compact. 0.92. What is the ratio of the PPP conversion factor (LCU per international $) of Bolivia in 2008 to that in 2010?
Provide a short and direct response. 0.96. What is the ratio of the PPP conversion factor (LCU per international $) of Cote d'Ivoire in 2008 to that in 2010?
Provide a short and direct response. 0.95. What is the ratio of the PPP conversion factor (LCU per international $) of Bhutan in 2008 to that in 2011?
Your answer should be compact. 0.86. What is the ratio of the PPP conversion factor (LCU per international $) of Bolivia in 2008 to that in 2011?
Provide a short and direct response. 0.86. What is the ratio of the PPP conversion factor (LCU per international $) of Cote d'Ivoire in 2008 to that in 2011?
Give a very brief answer. 0.95. What is the ratio of the PPP conversion factor (LCU per international $) of Bhutan in 2008 to that in 2012?
Provide a succinct answer. 0.8. What is the ratio of the PPP conversion factor (LCU per international $) of Bolivia in 2008 to that in 2012?
Provide a succinct answer. 0.81. What is the ratio of the PPP conversion factor (LCU per international $) of Cote d'Ivoire in 2008 to that in 2012?
Provide a short and direct response. 0.93. What is the ratio of the PPP conversion factor (LCU per international $) in Bhutan in 2008 to that in 2013?
Provide a short and direct response. 0.77. What is the ratio of the PPP conversion factor (LCU per international $) in Bolivia in 2008 to that in 2013?
Offer a very short reply. 0.78. What is the ratio of the PPP conversion factor (LCU per international $) of Cote d'Ivoire in 2008 to that in 2013?
Offer a terse response. 0.92. What is the ratio of the PPP conversion factor (LCU per international $) in Bhutan in 2008 to that in 2014?
Your answer should be compact. 0.73. What is the ratio of the PPP conversion factor (LCU per international $) of Bolivia in 2008 to that in 2014?
Make the answer very short. 0.77. What is the ratio of the PPP conversion factor (LCU per international $) of Cote d'Ivoire in 2008 to that in 2014?
Offer a very short reply. 0.92. What is the ratio of the PPP conversion factor (LCU per international $) in Bhutan in 2009 to that in 2010?
Keep it short and to the point. 0.95. What is the ratio of the PPP conversion factor (LCU per international $) in Bolivia in 2009 to that in 2010?
Provide a short and direct response. 0.93. What is the ratio of the PPP conversion factor (LCU per international $) of Cote d'Ivoire in 2009 to that in 2010?
Offer a terse response. 0.96. What is the ratio of the PPP conversion factor (LCU per international $) of Bhutan in 2009 to that in 2011?
Keep it short and to the point. 0.9. What is the ratio of the PPP conversion factor (LCU per international $) in Bolivia in 2009 to that in 2011?
Offer a very short reply. 0.83. What is the ratio of the PPP conversion factor (LCU per international $) of Cote d'Ivoire in 2009 to that in 2011?
Provide a succinct answer. 0.96. What is the ratio of the PPP conversion factor (LCU per international $) of Bhutan in 2009 to that in 2012?
Provide a short and direct response. 0.84. What is the ratio of the PPP conversion factor (LCU per international $) in Bolivia in 2009 to that in 2012?
Keep it short and to the point. 0.79. What is the ratio of the PPP conversion factor (LCU per international $) of Cote d'Ivoire in 2009 to that in 2012?
Your answer should be very brief. 0.94. What is the ratio of the PPP conversion factor (LCU per international $) of Bhutan in 2009 to that in 2013?
Give a very brief answer. 0.8. What is the ratio of the PPP conversion factor (LCU per international $) in Bolivia in 2009 to that in 2013?
Provide a short and direct response. 0.75. What is the ratio of the PPP conversion factor (LCU per international $) of Cote d'Ivoire in 2009 to that in 2013?
Your answer should be very brief. 0.93. What is the ratio of the PPP conversion factor (LCU per international $) of Bhutan in 2009 to that in 2014?
Provide a short and direct response. 0.76. What is the ratio of the PPP conversion factor (LCU per international $) in Bolivia in 2009 to that in 2014?
Provide a succinct answer. 0.75. What is the ratio of the PPP conversion factor (LCU per international $) in Cote d'Ivoire in 2009 to that in 2014?
Your answer should be compact. 0.94. What is the ratio of the PPP conversion factor (LCU per international $) in Bhutan in 2010 to that in 2011?
Offer a terse response. 0.94. What is the ratio of the PPP conversion factor (LCU per international $) of Bolivia in 2010 to that in 2011?
Give a very brief answer. 0.89. What is the ratio of the PPP conversion factor (LCU per international $) of Bhutan in 2010 to that in 2012?
Keep it short and to the point. 0.88. What is the ratio of the PPP conversion factor (LCU per international $) in Bolivia in 2010 to that in 2012?
Give a very brief answer. 0.85. What is the ratio of the PPP conversion factor (LCU per international $) of Cote d'Ivoire in 2010 to that in 2012?
Keep it short and to the point. 0.98. What is the ratio of the PPP conversion factor (LCU per international $) in Bhutan in 2010 to that in 2013?
Offer a very short reply. 0.84. What is the ratio of the PPP conversion factor (LCU per international $) of Bolivia in 2010 to that in 2013?
Ensure brevity in your answer.  0.81. What is the ratio of the PPP conversion factor (LCU per international $) in Cote d'Ivoire in 2010 to that in 2013?
Your answer should be compact. 0.97. What is the ratio of the PPP conversion factor (LCU per international $) in Bhutan in 2010 to that in 2014?
Give a very brief answer. 0.79. What is the ratio of the PPP conversion factor (LCU per international $) of Bolivia in 2010 to that in 2014?
Keep it short and to the point. 0.81. What is the ratio of the PPP conversion factor (LCU per international $) in Cote d'Ivoire in 2010 to that in 2014?
Ensure brevity in your answer.  0.98. What is the ratio of the PPP conversion factor (LCU per international $) of Bhutan in 2011 to that in 2012?
Offer a very short reply. 0.93. What is the ratio of the PPP conversion factor (LCU per international $) of Bolivia in 2011 to that in 2012?
Keep it short and to the point. 0.95. What is the ratio of the PPP conversion factor (LCU per international $) in Cote d'Ivoire in 2011 to that in 2012?
Provide a short and direct response. 0.98. What is the ratio of the PPP conversion factor (LCU per international $) of Bhutan in 2011 to that in 2013?
Offer a very short reply. 0.89. What is the ratio of the PPP conversion factor (LCU per international $) in Bolivia in 2011 to that in 2013?
Your answer should be very brief. 0.91. What is the ratio of the PPP conversion factor (LCU per international $) of Bhutan in 2011 to that in 2014?
Your answer should be compact. 0.84. What is the ratio of the PPP conversion factor (LCU per international $) of Bolivia in 2011 to that in 2014?
Keep it short and to the point. 0.9. What is the ratio of the PPP conversion factor (LCU per international $) in Cote d'Ivoire in 2011 to that in 2014?
Ensure brevity in your answer.  0.97. What is the ratio of the PPP conversion factor (LCU per international $) of Bhutan in 2012 to that in 2013?
Provide a short and direct response. 0.96. What is the ratio of the PPP conversion factor (LCU per international $) in Bolivia in 2012 to that in 2013?
Your answer should be very brief. 0.96. What is the ratio of the PPP conversion factor (LCU per international $) in Bhutan in 2012 to that in 2014?
Give a very brief answer. 0.9. What is the ratio of the PPP conversion factor (LCU per international $) in Bolivia in 2012 to that in 2014?
Give a very brief answer. 0.95. What is the ratio of the PPP conversion factor (LCU per international $) in Bhutan in 2013 to that in 2014?
Provide a succinct answer. 0.94. What is the ratio of the PPP conversion factor (LCU per international $) in Bolivia in 2013 to that in 2014?
Provide a succinct answer. 0.99. What is the difference between the highest and the second highest PPP conversion factor (LCU per international $) of Bhutan?
Provide a succinct answer. 1.14. What is the difference between the highest and the second highest PPP conversion factor (LCU per international $) of Bolivia?
Provide a short and direct response. 0.02. What is the difference between the highest and the second highest PPP conversion factor (LCU per international $) in Cote d'Ivoire?
Provide a succinct answer. 1.25. What is the difference between the highest and the lowest PPP conversion factor (LCU per international $) of Bhutan?
Offer a terse response. 5.96. What is the difference between the highest and the lowest PPP conversion factor (LCU per international $) of Bolivia?
Provide a short and direct response. 0.93. What is the difference between the highest and the lowest PPP conversion factor (LCU per international $) in Cote d'Ivoire?
Provide a succinct answer. 32.18. 